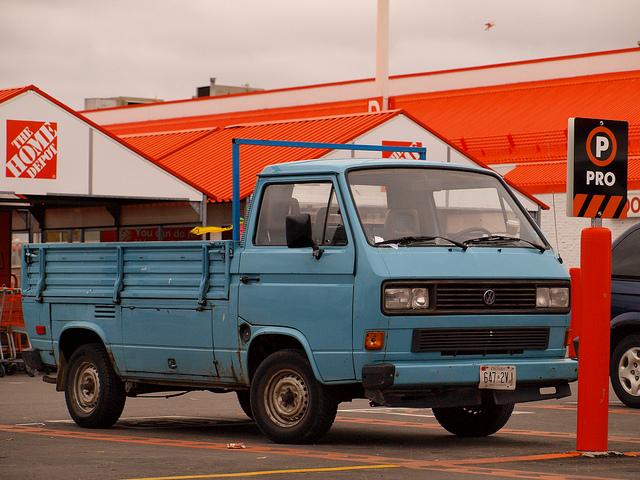Is this a modern truck?
Concise answer only. No. Is this a Japanese vehicle?
Concise answer only. No. What store's parking lot is this?
Write a very short answer. Home depot. What color is the truck?
Give a very brief answer. Blue. What is the color of the truck?
Keep it brief. Blue. 